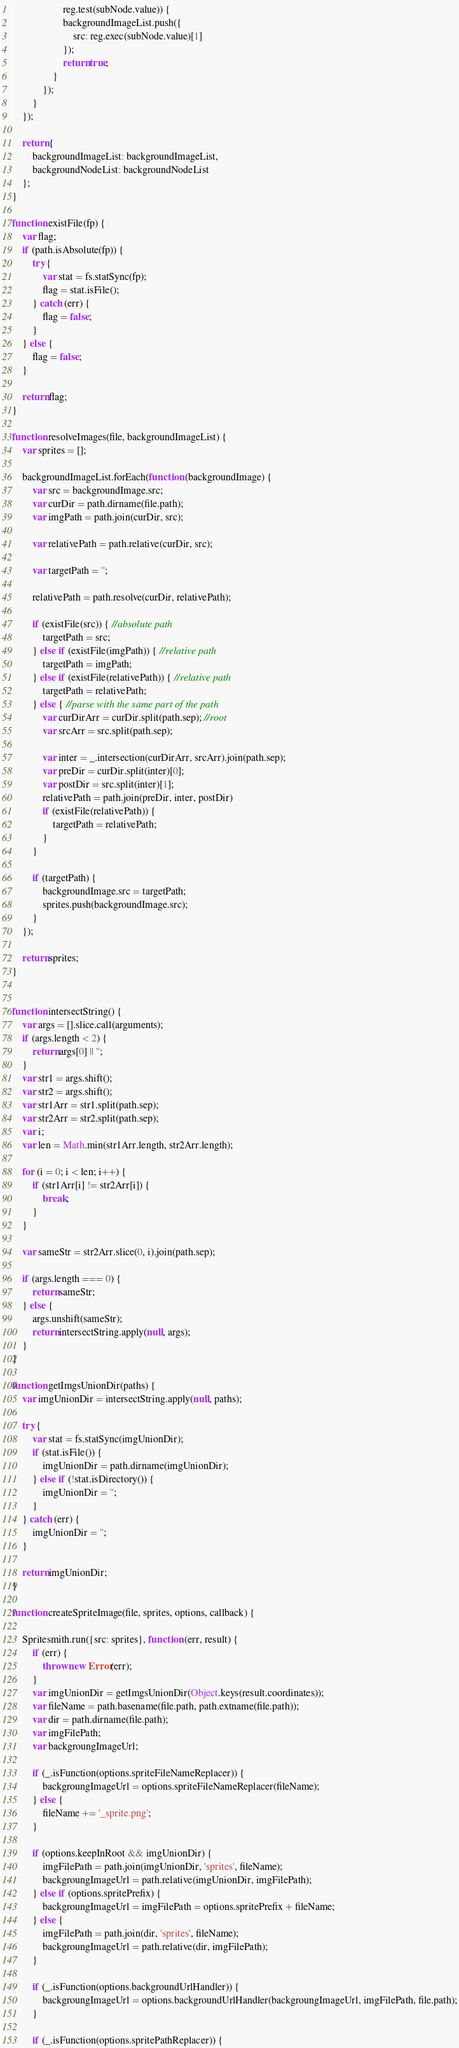Convert code to text. <code><loc_0><loc_0><loc_500><loc_500><_JavaScript_>                    reg.test(subNode.value)) {
                    backgroundImageList.push({
                        src: reg.exec(subNode.value)[1]
                    });
                    return true;
                }
            });
        }
    });

    return {
        backgroundImageList: backgroundImageList,
        backgroundNodeList: backgroundNodeList
    };
}

function existFile(fp) {
    var flag;
    if (path.isAbsolute(fp)) {
        try {
            var stat = fs.statSync(fp);
            flag = stat.isFile();
        } catch (err) {
            flag = false;
        }
    } else {
        flag = false;
    }

    return flag;
}

function resolveImages(file, backgroundImageList) {
    var sprites = [];

    backgroundImageList.forEach(function (backgroundImage) {
        var src = backgroundImage.src;
        var curDir = path.dirname(file.path);
        var imgPath = path.join(curDir, src);

        var relativePath = path.relative(curDir, src);

        var targetPath = '';

        relativePath = path.resolve(curDir, relativePath);

        if (existFile(src)) { //absolute path
            targetPath = src;
        } else if (existFile(imgPath)) { //relative path
            targetPath = imgPath;
        } else if (existFile(relativePath)) { //relative path
            targetPath = relativePath;
        } else { //parse with the same part of the path
            var curDirArr = curDir.split(path.sep); //root
            var srcArr = src.split(path.sep);

            var inter = _.intersection(curDirArr, srcArr).join(path.sep);
            var preDir = curDir.split(inter)[0];
            var postDir = src.split(inter)[1];
            relativePath = path.join(preDir, inter, postDir)
            if (existFile(relativePath)) {
                targetPath = relativePath;
            }
        }

        if (targetPath) {
            backgroundImage.src = targetPath;
            sprites.push(backgroundImage.src);
        }
    });

    return sprites;
}


function intersectString() {
    var args = [].slice.call(arguments);
    if (args.length < 2) {
        return args[0] || '';
    }
    var str1 = args.shift();
    var str2 = args.shift();
    var str1Arr = str1.split(path.sep);
    var str2Arr = str2.split(path.sep);
    var i;
    var len = Math.min(str1Arr.length, str2Arr.length);

    for (i = 0; i < len; i++) {
        if (str1Arr[i] != str2Arr[i]) {
            break;
        }
    }

    var sameStr = str2Arr.slice(0, i).join(path.sep);

    if (args.length === 0) {
        return sameStr;
    } else {
        args.unshift(sameStr);
        return intersectString.apply(null, args);
    }
}

function getImgsUnionDir(paths) {
    var imgUnionDir = intersectString.apply(null, paths);

    try {
        var stat = fs.statSync(imgUnionDir);
        if (stat.isFile()) {
            imgUnionDir = path.dirname(imgUnionDir);
        } else if (!stat.isDirectory()) {
            imgUnionDir = '';
        }
    } catch (err) {
        imgUnionDir = '';
    }

    return imgUnionDir;
}

function createSpriteImage(file, sprites, options, callback) {

    Spritesmith.run({src: sprites}, function (err, result) {
        if (err) {
            throw new Error(err);
        }
        var imgUnionDir = getImgsUnionDir(Object.keys(result.coordinates));
        var fileName = path.basename(file.path, path.extname(file.path));
        var dir = path.dirname(file.path);
        var imgFilePath;
        var backgroungImageUrl;

        if (_.isFunction(options.spriteFileNameReplacer)) {
            backgroungImageUrl = options.spriteFileNameReplacer(fileName);
        } else {
            fileName += '_sprite.png';
        }

        if (options.keepInRoot && imgUnionDir) {
            imgFilePath = path.join(imgUnionDir, 'sprites', fileName);
            backgroungImageUrl = path.relative(imgUnionDir, imgFilePath);
        } else if (options.spritePrefix) {
            backgroungImageUrl = imgFilePath = options.spritePrefix + fileName;
        } else {
            imgFilePath = path.join(dir, 'sprites', fileName);
            backgroungImageUrl = path.relative(dir, imgFilePath);
        }

        if (_.isFunction(options.backgroundUrlHandler)) {
            backgroungImageUrl = options.backgroundUrlHandler(backgroungImageUrl, imgFilePath, file.path);
        }

        if (_.isFunction(options.spritePathReplacer)) {</code> 